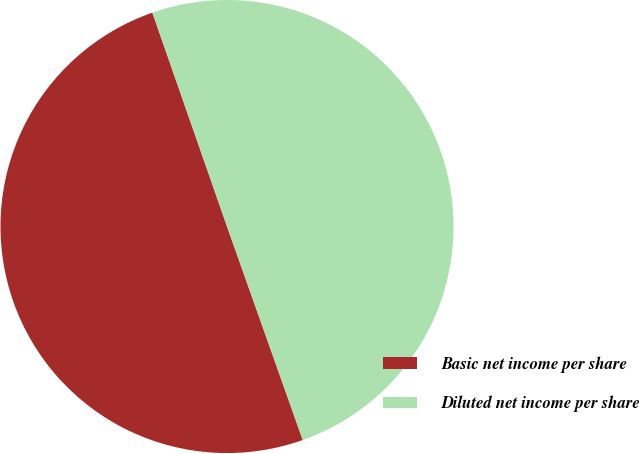<chart> <loc_0><loc_0><loc_500><loc_500><pie_chart><fcel>Basic net income per share<fcel>Diluted net income per share<nl><fcel>50.08%<fcel>49.92%<nl></chart> 